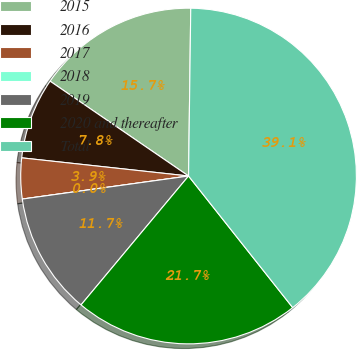<chart> <loc_0><loc_0><loc_500><loc_500><pie_chart><fcel>2015<fcel>2016<fcel>2017<fcel>2018<fcel>2019<fcel>2020 and thereafter<fcel>Total<nl><fcel>15.65%<fcel>7.83%<fcel>3.92%<fcel>0.0%<fcel>11.74%<fcel>21.72%<fcel>39.13%<nl></chart> 